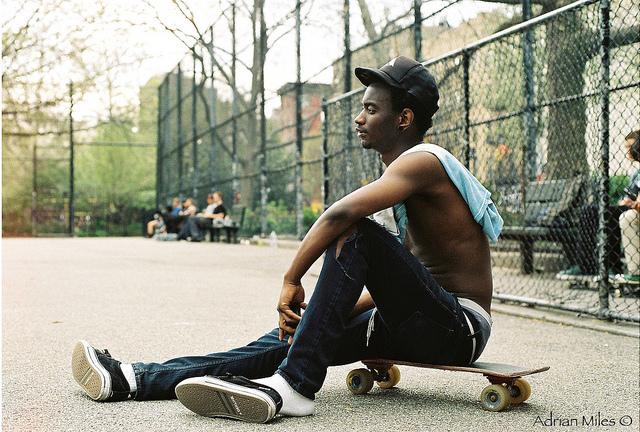What type of sneaker's does the person have?
Be succinct. Vans. What is the man sitting on?
Give a very brief answer. Skateboard. Is there any special reason this man has his shirt off?
Answer briefly. No. 